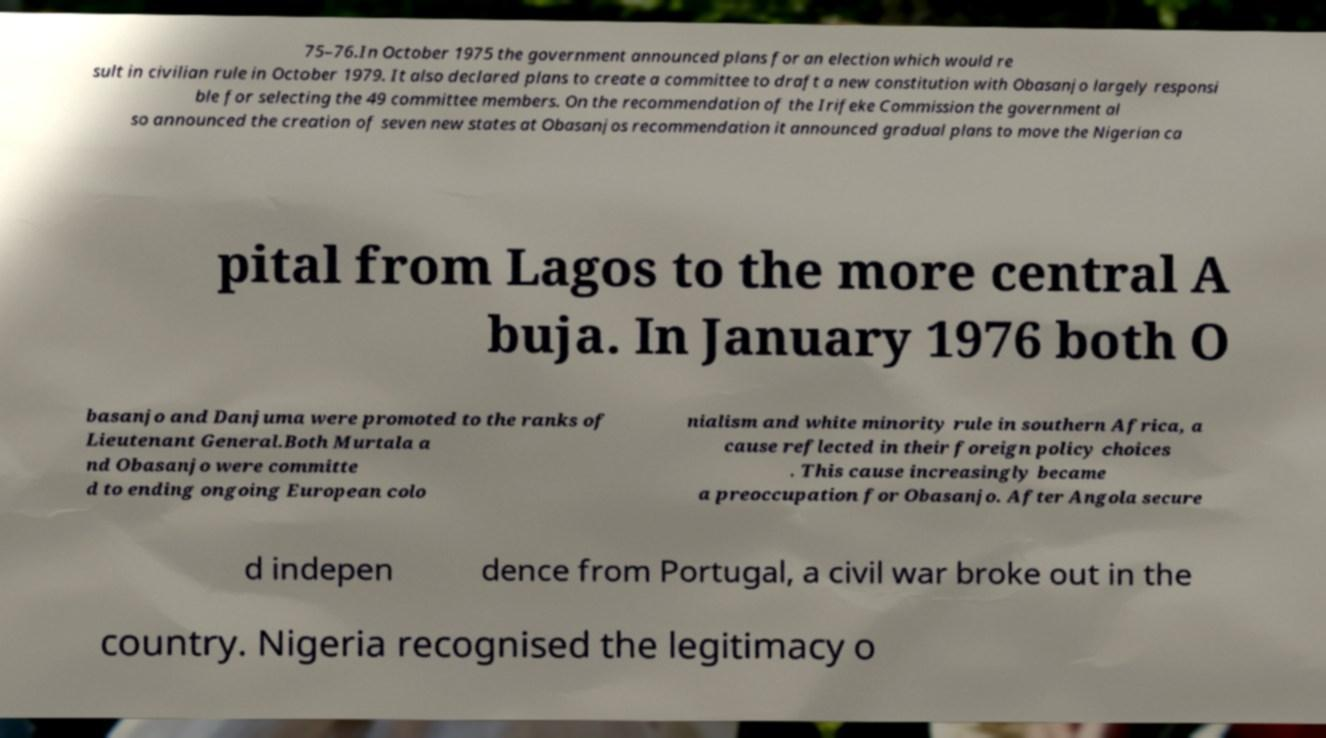Please read and relay the text visible in this image. What does it say? 75–76.In October 1975 the government announced plans for an election which would re sult in civilian rule in October 1979. It also declared plans to create a committee to draft a new constitution with Obasanjo largely responsi ble for selecting the 49 committee members. On the recommendation of the Irifeke Commission the government al so announced the creation of seven new states at Obasanjos recommendation it announced gradual plans to move the Nigerian ca pital from Lagos to the more central A buja. In January 1976 both O basanjo and Danjuma were promoted to the ranks of Lieutenant General.Both Murtala a nd Obasanjo were committe d to ending ongoing European colo nialism and white minority rule in southern Africa, a cause reflected in their foreign policy choices . This cause increasingly became a preoccupation for Obasanjo. After Angola secure d indepen dence from Portugal, a civil war broke out in the country. Nigeria recognised the legitimacy o 